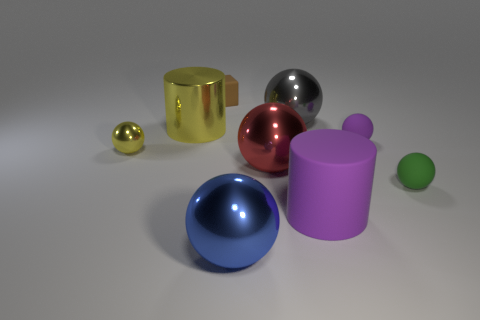Subtract 1 spheres. How many spheres are left? 5 Subtract all tiny yellow spheres. How many spheres are left? 5 Subtract all yellow spheres. How many spheres are left? 5 Add 1 big cylinders. How many objects exist? 10 Subtract all yellow balls. Subtract all purple cylinders. How many balls are left? 5 Subtract all balls. How many objects are left? 3 Subtract all small brown rubber objects. Subtract all large purple cylinders. How many objects are left? 7 Add 4 small yellow things. How many small yellow things are left? 5 Add 7 red rubber cylinders. How many red rubber cylinders exist? 7 Subtract 0 purple blocks. How many objects are left? 9 